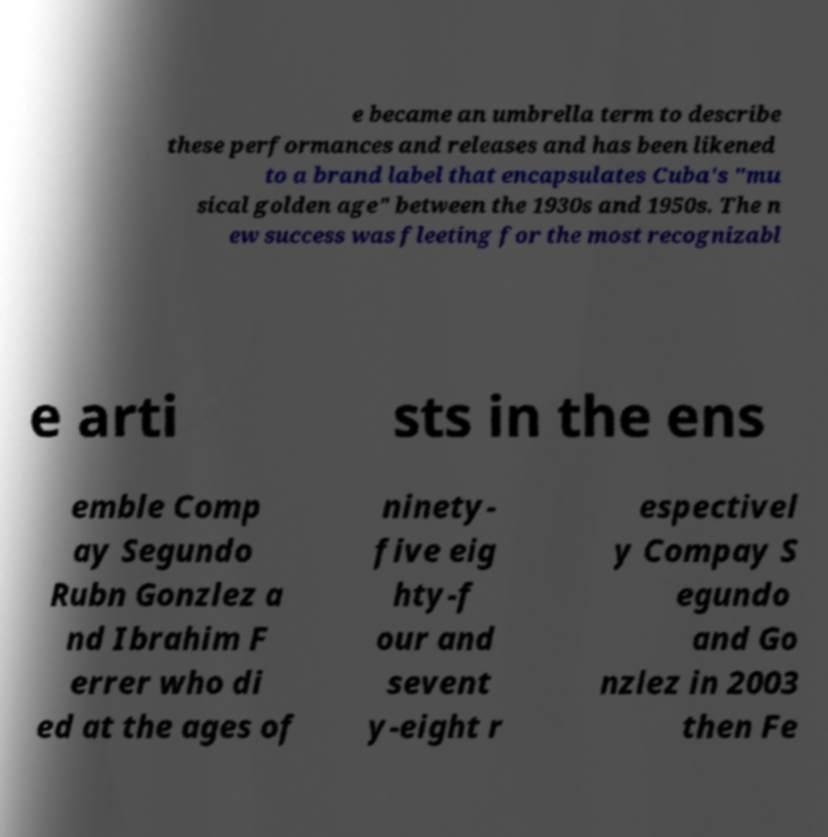Could you extract and type out the text from this image? e became an umbrella term to describe these performances and releases and has been likened to a brand label that encapsulates Cuba's "mu sical golden age" between the 1930s and 1950s. The n ew success was fleeting for the most recognizabl e arti sts in the ens emble Comp ay Segundo Rubn Gonzlez a nd Ibrahim F errer who di ed at the ages of ninety- five eig hty-f our and sevent y-eight r espectivel y Compay S egundo and Go nzlez in 2003 then Fe 